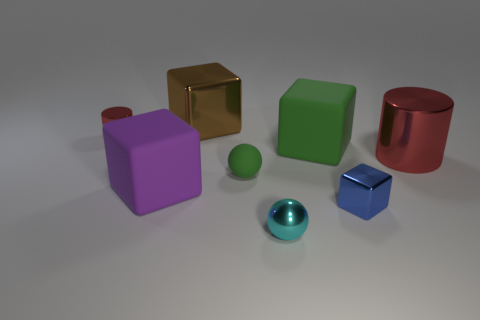Are there any other things that are the same shape as the tiny blue metal thing?
Make the answer very short. Yes. There is a big cube that is on the left side of the large metal object that is behind the shiny cylinder that is behind the large red thing; what color is it?
Give a very brief answer. Purple. There is a object that is both in front of the tiny red shiny cylinder and left of the large brown metallic thing; what shape is it?
Your response must be concise. Cube. Is there anything else that is the same size as the brown cube?
Your answer should be compact. Yes. The shiny cube that is in front of the red cylinder that is on the left side of the purple thing is what color?
Your answer should be very brief. Blue. There is a large object behind the shiny cylinder behind the big cube to the right of the brown block; what shape is it?
Provide a short and direct response. Cube. What is the size of the thing that is both to the right of the small cyan ball and on the left side of the small blue shiny block?
Your response must be concise. Large. What number of small rubber things have the same color as the metal sphere?
Your answer should be compact. 0. There is a large object that is the same color as the small cylinder; what is it made of?
Make the answer very short. Metal. What is the material of the large red object?
Offer a very short reply. Metal. 